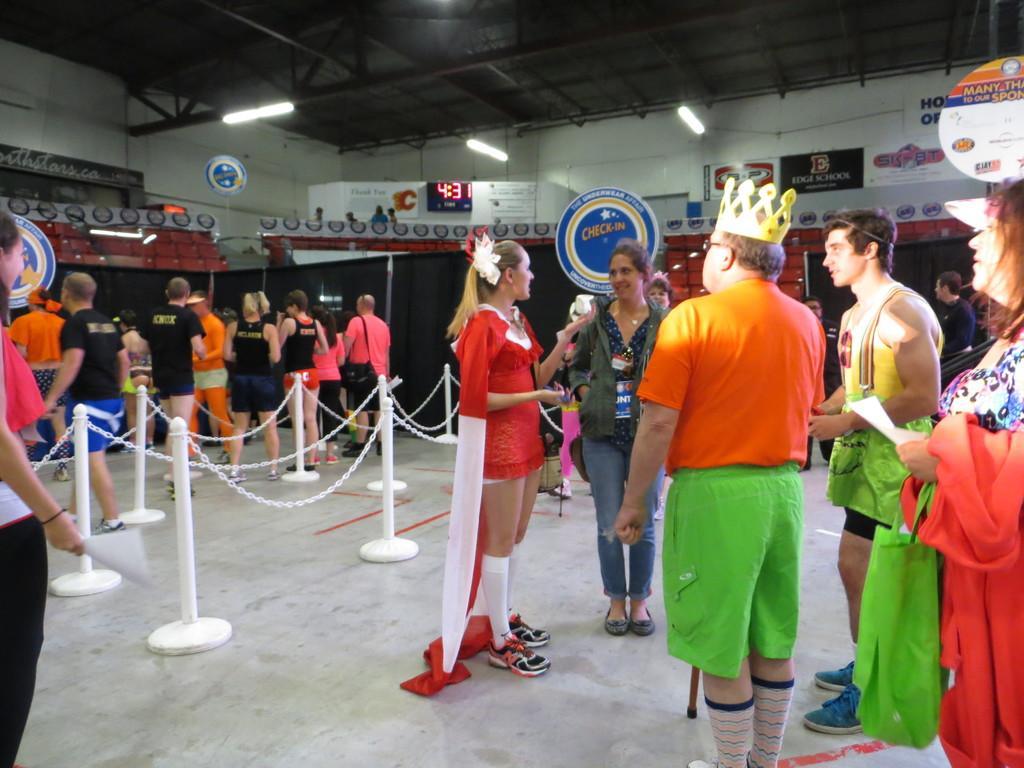Can you describe this image briefly? This image consists of many people. At the bottom, there is a floor. In the middle, we can see a fencing along with poles and chains. In the background, there are black clothes. At the top, there is a roof along with light. And we can see a digital clock along with the banners. 